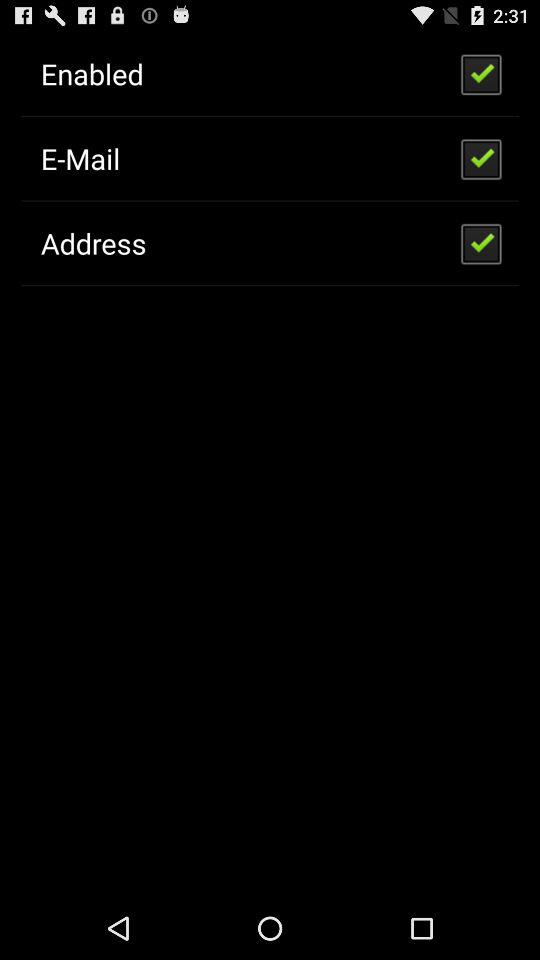How many checkboxes are not checked?
Answer the question using a single word or phrase. 2 